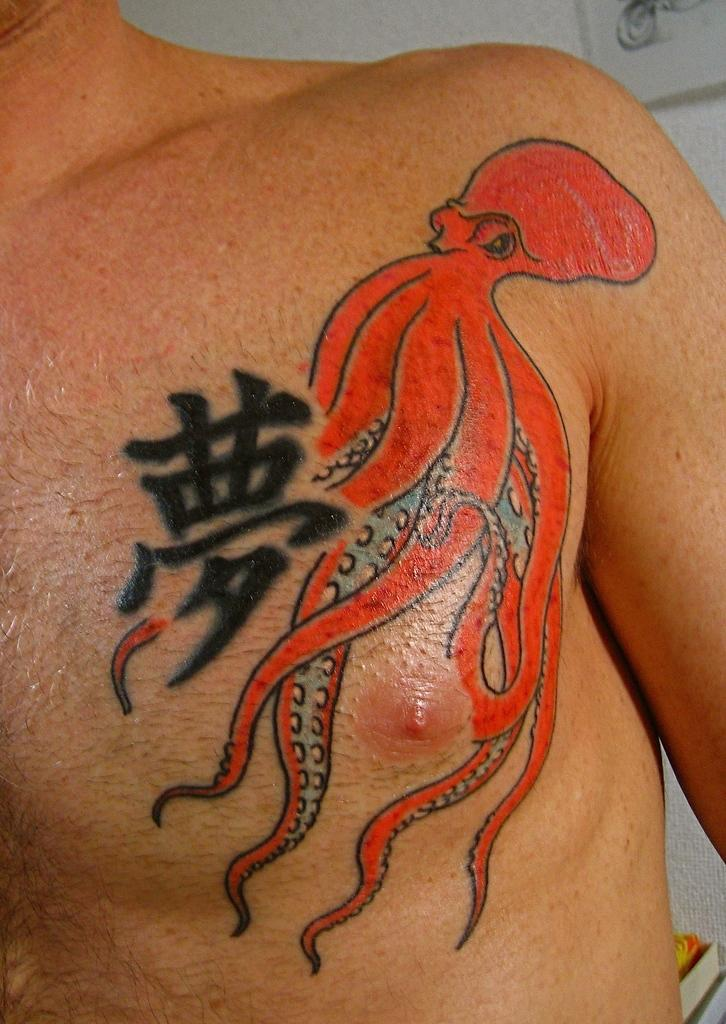What is present in the image? There is a person in the image. Can you describe any distinguishing features of the person? The person has a tattoo. What can be seen in the background of the image? There is a wall in the background of the image. What type of pencil is the person holding in the image? There is no pencil present in the image. How many heads does the person have in the image? The person has one head in the image. 